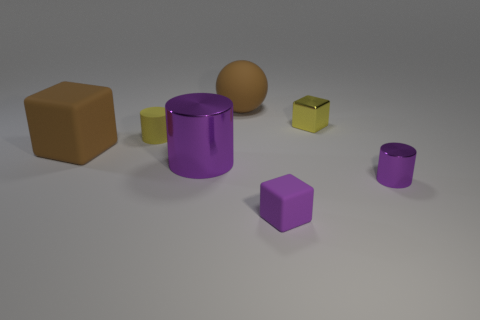Does the purple matte block have the same size as the yellow shiny thing?
Offer a very short reply. Yes. What number of small blue cylinders have the same material as the big cylinder?
Give a very brief answer. 0. There is a brown rubber thing that is the same shape as the purple rubber object; what is its size?
Make the answer very short. Large. Is the shape of the brown thing that is to the left of the tiny yellow cylinder the same as  the small yellow metal thing?
Your answer should be compact. Yes. There is a purple metallic thing to the left of the brown thing to the right of the tiny yellow cylinder; what shape is it?
Ensure brevity in your answer.  Cylinder. The large rubber thing that is the same shape as the yellow metal thing is what color?
Your answer should be compact. Brown. Does the small metallic cylinder have the same color as the rubber thing that is in front of the big purple thing?
Your answer should be very brief. Yes. There is a object that is on the left side of the tiny yellow metallic cube and behind the small yellow matte cylinder; what is its shape?
Provide a short and direct response. Sphere. Is the number of tiny brown rubber things less than the number of big purple metal cylinders?
Make the answer very short. Yes. Is there a large cyan shiny sphere?
Give a very brief answer. No. 